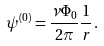Convert formula to latex. <formula><loc_0><loc_0><loc_500><loc_500>\psi ^ { ( 0 ) } = \frac { \nu \Phi _ { 0 } } { 2 \pi } \frac { 1 } { r } \, .</formula> 